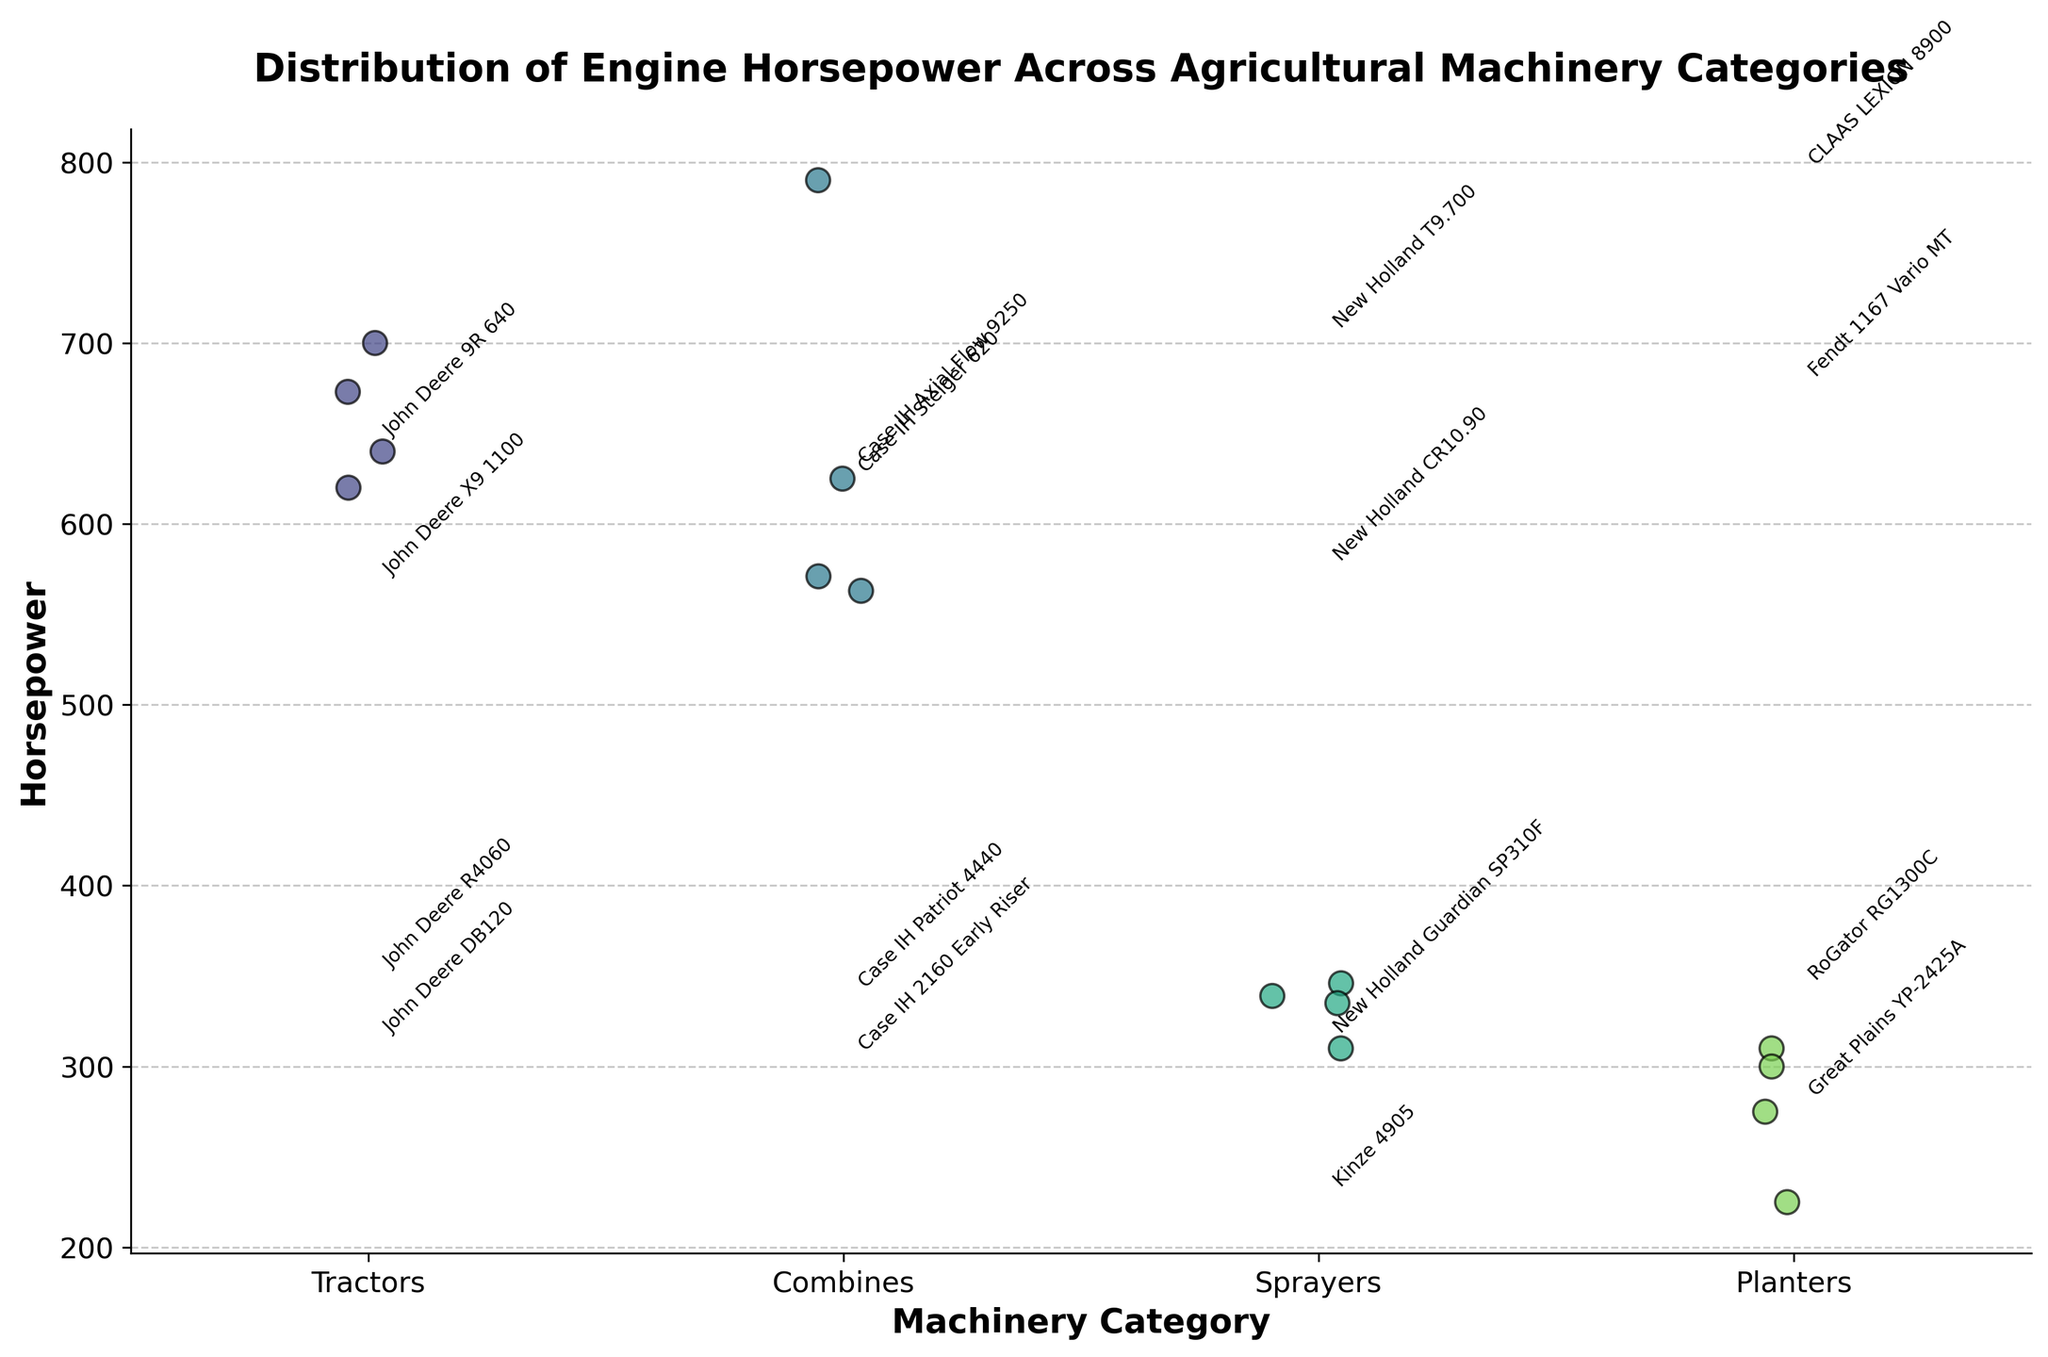what is the title of the plot? The title is displayed at the top of the figure in a larger and bold font. It reads "Distribution of Engine Horsepower Across Agricultural Machinery Categories".
Answer: Distribution of Engine Horsepower Across Agricultural Machinery Categories What categories of agricultural machinery are represented in the plot? The x-axis lists the categories in bold text. They include Tractors, Combines, Sprayers, and Planters.
Answer: Tractors, Combines, Sprayers, Planters Which category has the highest horsepower data point, and what is its value? By examining the y-axis, Combines have the highest data point at 790 horsepower.
Answer: Combines, 790 What is the range of horsepower values for the 'Planters' category? Observing the 'Planters' category's distribution, the lowest value is 225 and the highest is 310. So the range is 310 - 225.
Answer: 85 How does the range of horsepower in 'Sprayers' compare to 'Planters'? The y-axis shows that 'Sprayers' range from 310 to 346, giving a range of 36, while 'Planters' range is 85, showing 'Sprayers' have a narrower range.
Answer: Sprayers have a narrower range Which model has the highest horsepower in the 'Tractors' category? In the 'Tractors' category, the highest horsepower data point corresponds to the model New Holland T9.700 with 700 horsepower.
Answer: New Holland T9.700 On average, which category has higher horsepower: 'Tractors' or 'Combines'? Calculate the average horsepower for each category by summing the horsepower values and dividing by the number of data points. Tractors: (640 + 620 + 700 + 673) / 4 = 658.25, Combines: (563 + 625 + 571 + 790) / 4 = 637.25. Thus, 'Tractors' have a higher average horsepower.
Answer: Tractors Are there any models with the same horsepower in different categories? By detailed examination of horsepower values, both John Deere DB120 in 'Planters' and New Holland Guardian SP310F in 'Sprayers' have a horsepower of 310.
Answer: Yes What is the median horsepower for the 'Combines' category? Organize the values: (563, 571, 625, 790). The median is the average of the two middle values: (571 + 625) / 2 = 598.
Answer: 598 Identify the category with the most consistent horsepower values (i.e., smallest range). Observing the plot, 'Sprayers' show the smallest range of 36 horsepower (346 - 310).
Answer: Sprayers 